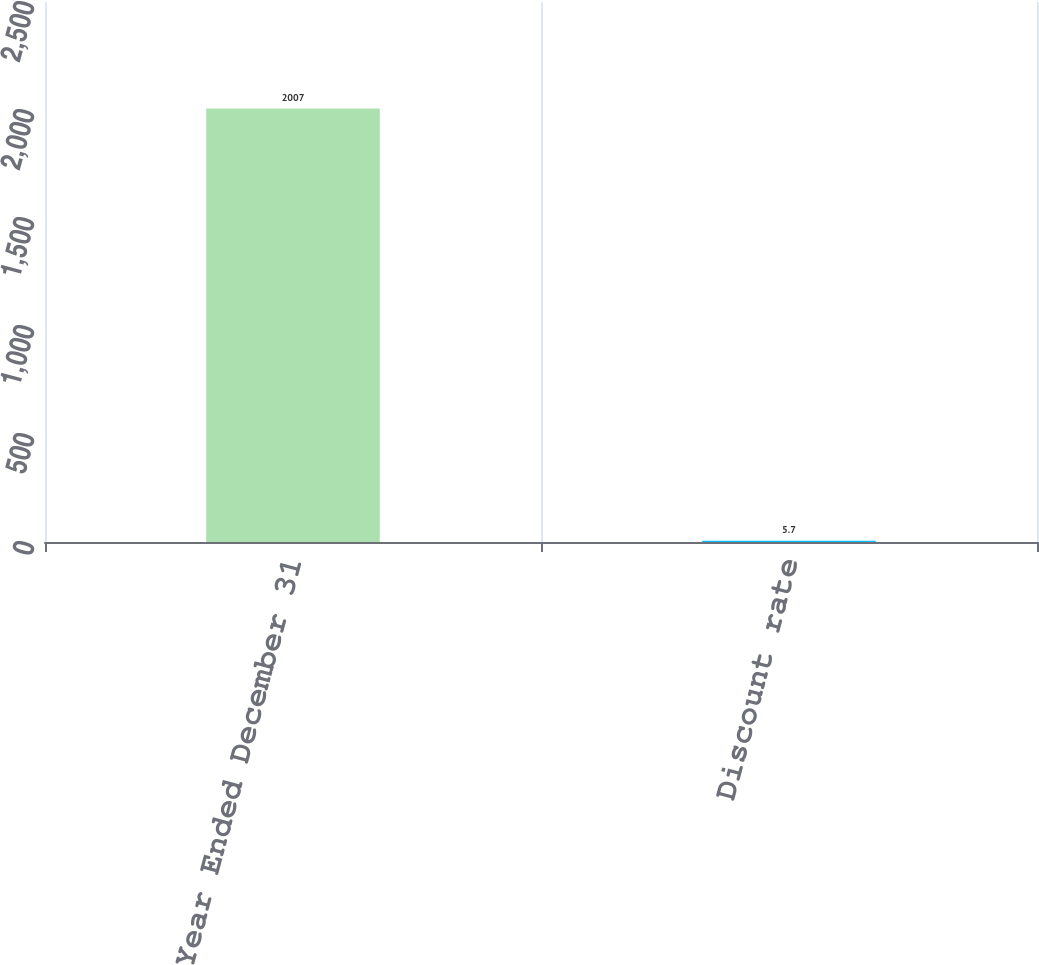Convert chart to OTSL. <chart><loc_0><loc_0><loc_500><loc_500><bar_chart><fcel>Year Ended December 31<fcel>Discount rate<nl><fcel>2007<fcel>5.7<nl></chart> 